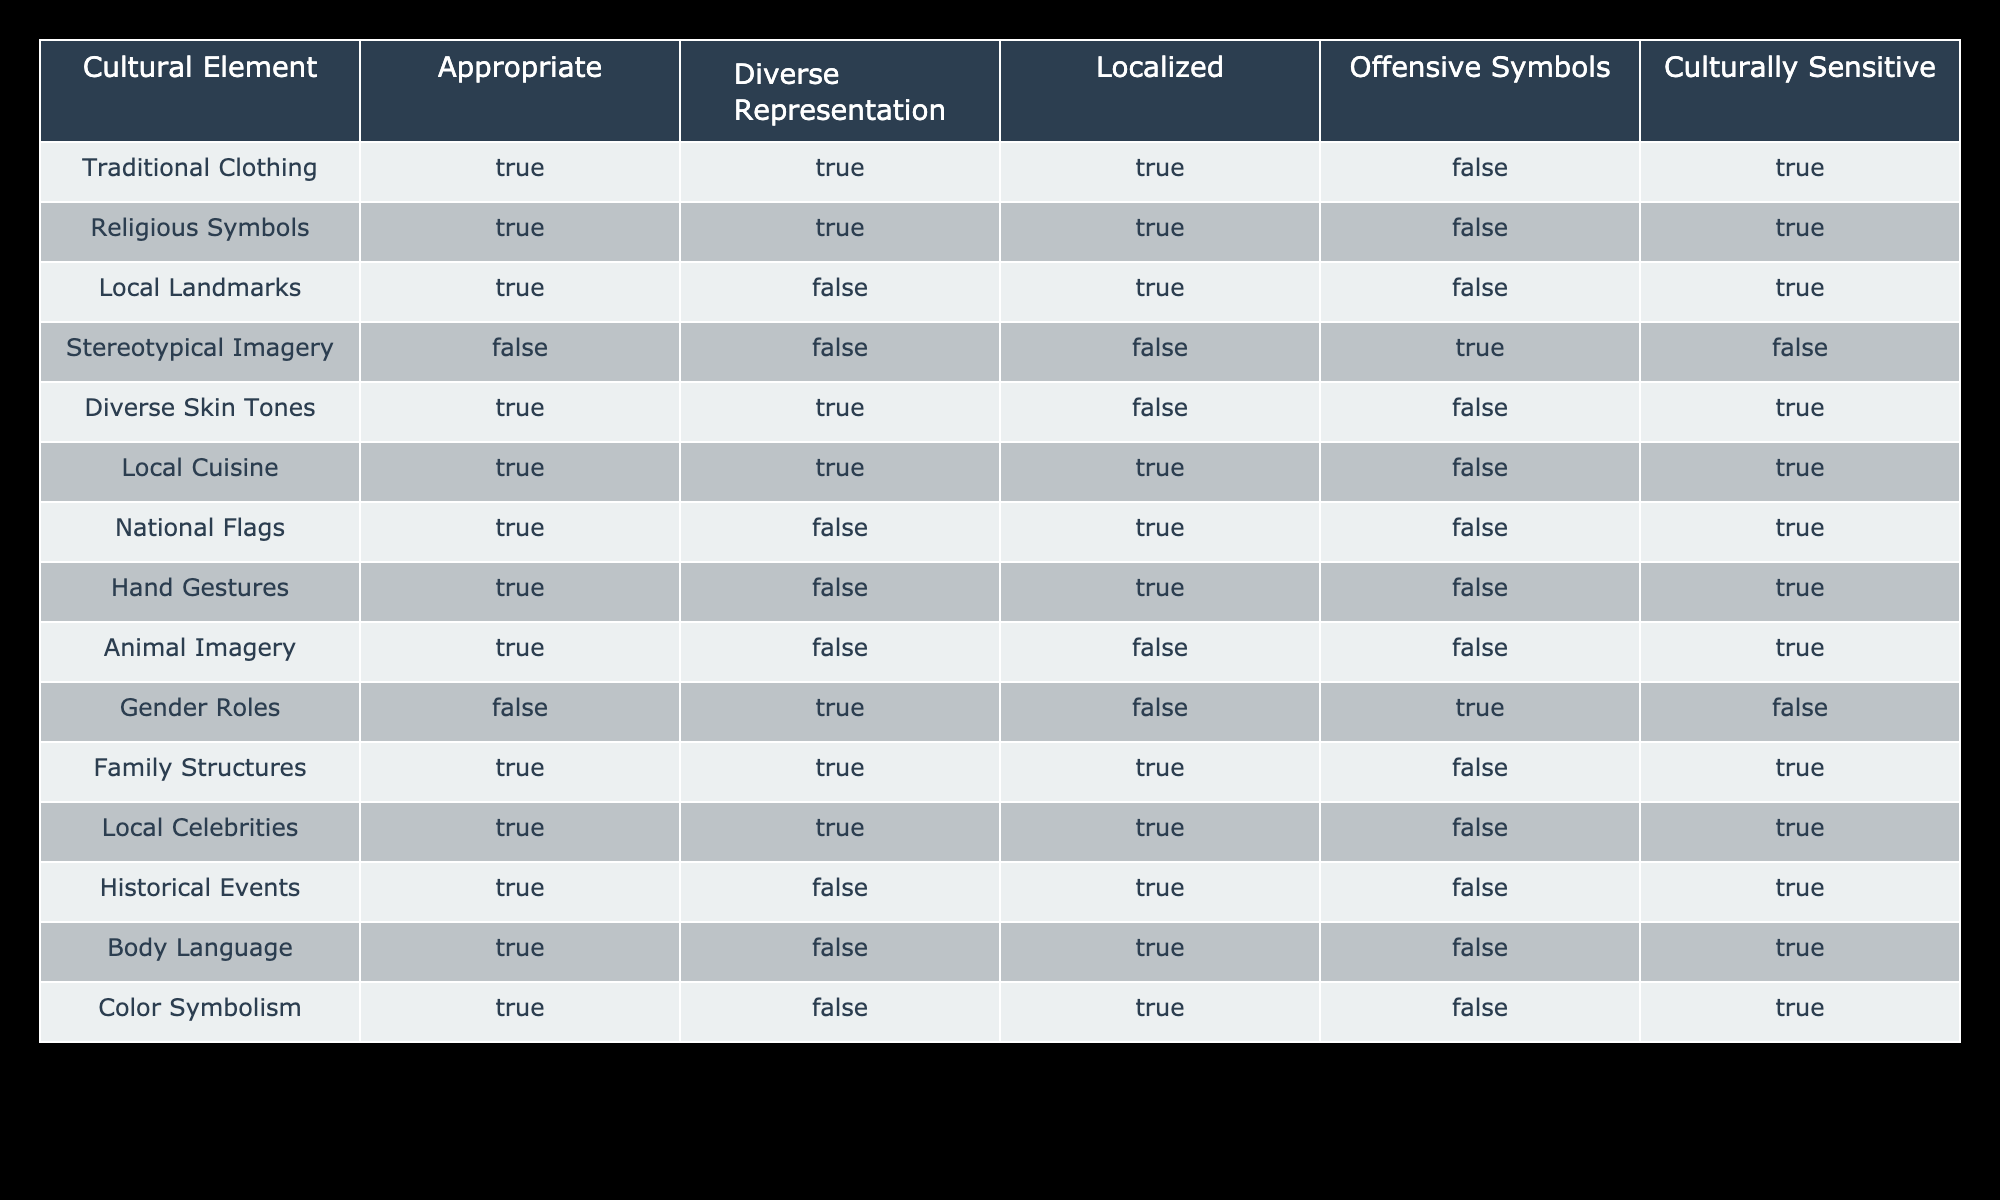What percentage of cultural elements are considered culturally sensitive? There are 20 cultural elements listed in the table. Of these, 12 are marked as culturally sensitive (TRUE under Culturally Sensitive). To calculate the percentage, divide the number of culturally sensitive elements (12) by the total number of elements (20) and multiply by 100: (12/20) * 100 = 60%.
Answer: 60% Is Local Landmarks considered to have Diverse Representation? In the table, Local Landmarks is marked as FALSE under Diverse Representation. This means that Local Landmarks do not represent diverse groups effectively.
Answer: No How many cultural elements are represented by traditional clothing, local cuisine, and family structures that are also culturally sensitive? We will look at each category: Traditional Clothing is culturally sensitive (TRUE), Local Cuisine is also culturally sensitive (TRUE), and Family Structures is culturally sensitive (TRUE). Adding these, we find that all three categories (3) are culturally sensitive.
Answer: 3 Which cultural element has offensive symbols and is not considered culturally sensitive? The table shows that the cultural element "Stereotypical Imagery" has TRUE under Offensive Symbols and FALSE under Culturally Sensitive. This element is therefore identified as containing offensive symbols and is not culturally sensitive.
Answer: Stereotypical Imagery Do more cultural elements represent diverse skin tones or gender roles in a culturally sensitive way? According to the table, Diverse Skin Tones are marked as culturally sensitive (TRUE), while Gender Roles are marked as culturally sensitive (FALSE). Since only Diverse Skin Tones are culturally sensitive, we conclude that they represent more diverse skin tones in a culturally sensitive way. Thus, there is one element (Diverse Skin Tones) that is culturally sensitive compared to zero for Gender Roles.
Answer: More cultural elements represent diverse skin tones 